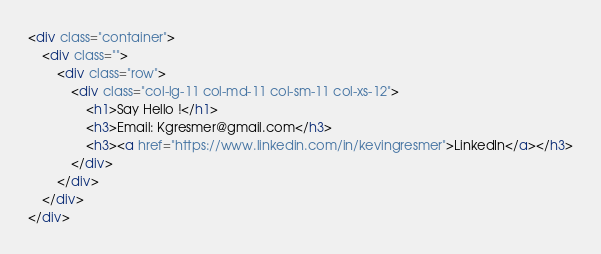Convert code to text. <code><loc_0><loc_0><loc_500><loc_500><_HTML_><div class="container">
    <div class="">
        <div class="row">
            <div class="col-lg-11 col-md-11 col-sm-11 col-xs-12">
                <h1>Say Hello !</h1>
                <h3>Email: Kgresmer@gmail.com</h3>
                <h3><a href="https://www.linkedin.com/in/kevingresmer">LinkedIn</a></h3>
            </div>
        </div>
    </div>
</div>

</code> 